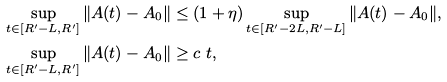Convert formula to latex. <formula><loc_0><loc_0><loc_500><loc_500>& \sup _ { t \in [ R ^ { \prime } - L , R ^ { \prime } ] } \| A ( t ) - A _ { 0 } \| \leq ( 1 + \eta ) \sup _ { t \in [ R ^ { \prime } - 2 L , R ^ { \prime } - L ] } \| A ( t ) - A _ { 0 } \| , \\ & \sup _ { t \in [ R ^ { \prime } - L , R ^ { \prime } ] } \| A ( t ) - A _ { 0 } \| \geq c \ t ,</formula> 